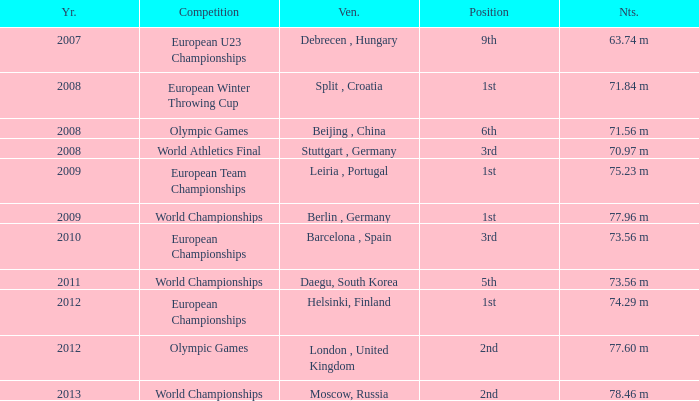Which Notes have a Competition of world championships, and a Position of 2nd? 78.46 m. 